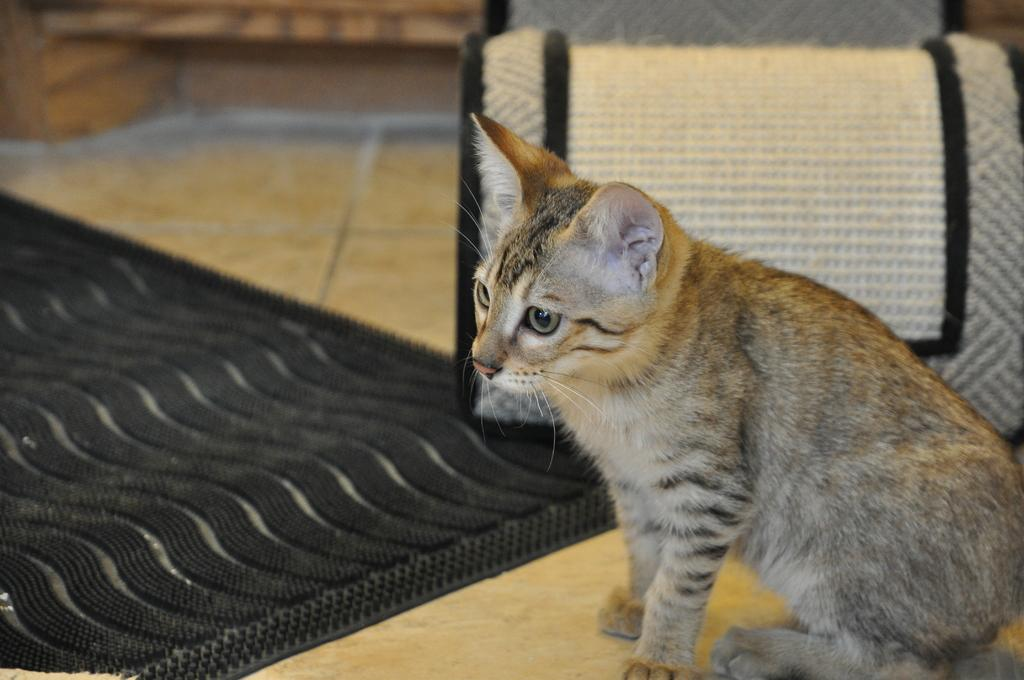What type of animal is on the right side of the image? There is a cat on the right side of the image. What is on the floor in the image? There is a rug on the floor. What piece of furniture can be seen in the background of the image? There is a chair in the background area of the image. What color is the paint on the cat's fur in the image? There is no paint mentioned or visible on the cat's fur in the image. 